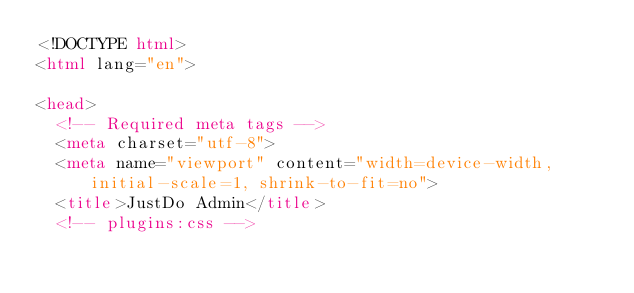Convert code to text. <code><loc_0><loc_0><loc_500><loc_500><_HTML_><!DOCTYPE html>
<html lang="en">

<head>
  <!-- Required meta tags -->
  <meta charset="utf-8">
  <meta name="viewport" content="width=device-width, initial-scale=1, shrink-to-fit=no">
  <title>JustDo Admin</title>
  <!-- plugins:css --></code> 